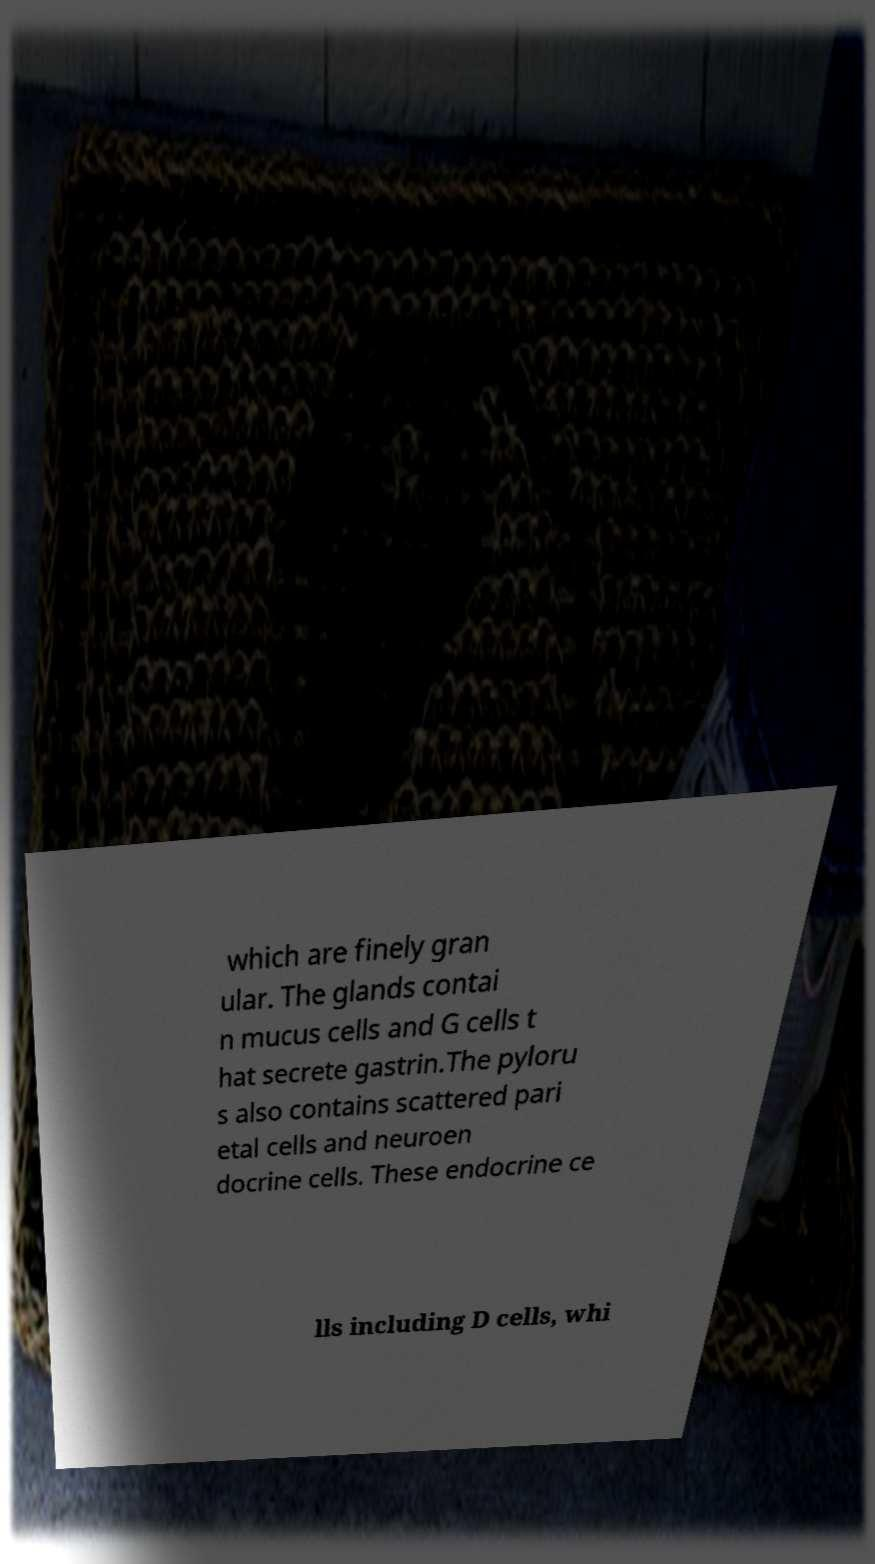Could you extract and type out the text from this image? which are finely gran ular. The glands contai n mucus cells and G cells t hat secrete gastrin.The pyloru s also contains scattered pari etal cells and neuroen docrine cells. These endocrine ce lls including D cells, whi 